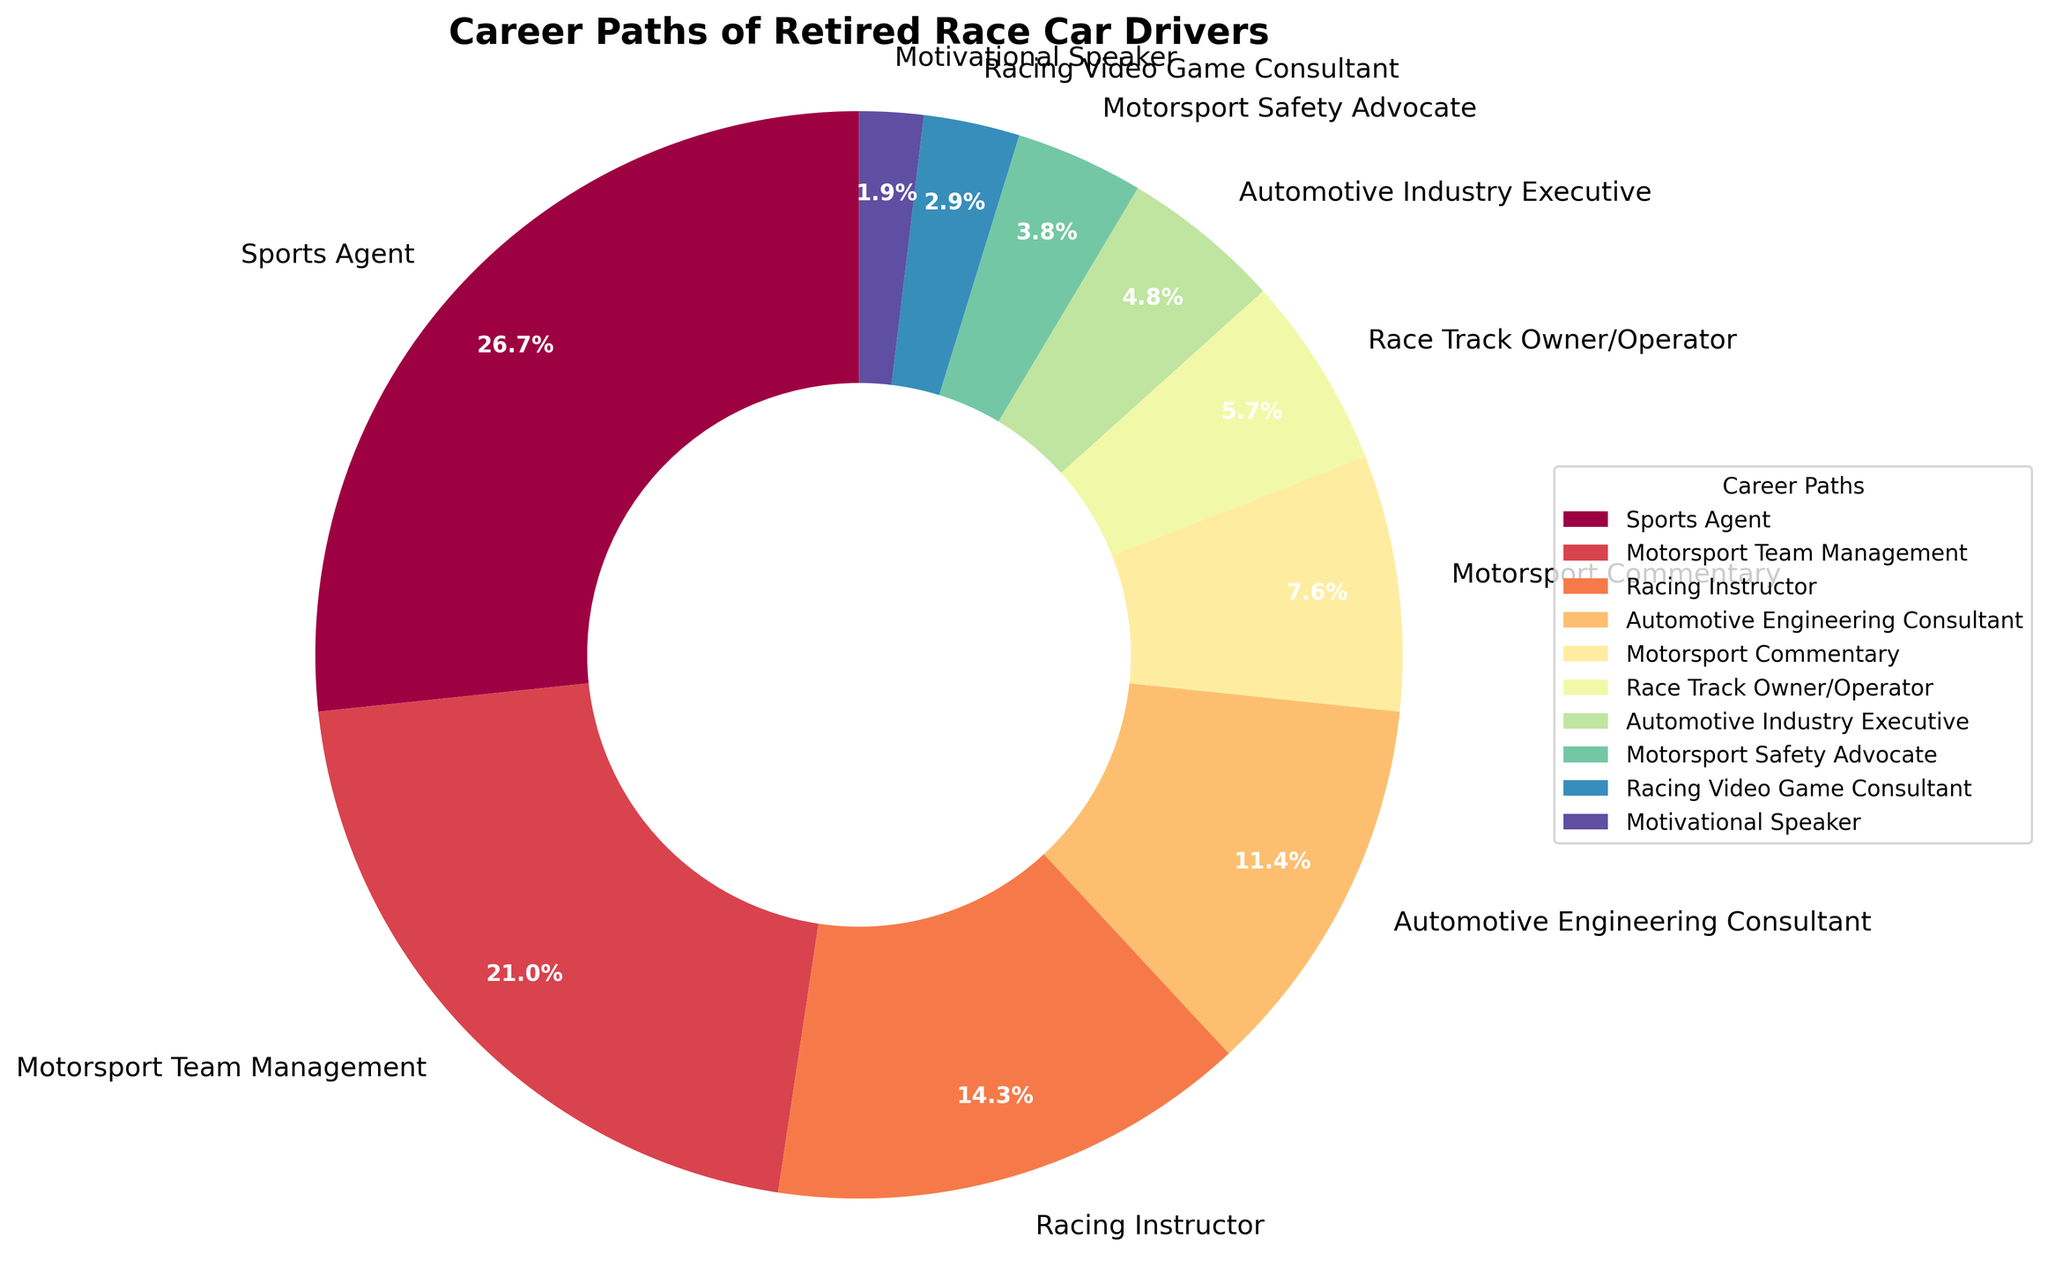What is the second most chosen career path for retired race car drivers? The pie chart segments show that "Motorsport Team Management" is the second largest segment after "Sports Agent".
Answer: Motorsport Team Management Which career path has the smallest percentage of retired race car drivers? The smallest segment in the pie chart signifies "Motivational Speaker" which has the smallest percentage.
Answer: Motivational Speaker What is the combined percentage of retired race car drivers who became Racing Instructors and Automotive Engineering Consultants? The percentages for "Racing Instructor" and "Automotive Engineering Consultant" are 15% and 12% respectively. Adding them together results in 27%.
Answer: 27% Compare the percentages of retired race car drivers who became Motorsport Commentary and Racing Video Game Consultants. Which is higher and by how much? "Motorsport Commentary" has 8%, while "Racing Video Game Consultant" has 3%. The difference is 8% - 3% = 5%.
Answer: Motorsport Commentary by 5% What percentage of retired race car drivers chose careers unrelated to motorsports? List these career paths. Careers unrelated to motorsports are "Motivational Speaker" (2%) and "Automotive Industry Executive" (5%). Adding these percentages results in 2% + 5% = 7%.
Answer: 7% Are there more retired race car drivers who became Motorsports Safety Advocates or Racing Video Game Consultants? The pie chart segments show that "Motorsport Safety Advocate" is at 4% whereas "Racing Video Game Consultant" is at 3%. Therefore, there are more Motorsports Safety Advocates.
Answer: Motorsports Safety Advocates Which career path is represented by the largest wedge on the pie chart? The largest wedge corresponds to the "Sports Agent" segment, at 28%.
Answer: Sports Agent What is the difference in percentage between the most chosen and the least chosen career paths? The most chosen career path is "Sports Agent" at 28% and the least chosen is "Motivational Speaker" at 2%. The difference is 28% - 2% = 26%.
Answer: 26% How many career paths captured in the pie chart have a percentage of 10% or more? The career paths with 10% or more are "Sports Agent" (28%), "Motorsport Team Management" (22%), "Racing Instructor" (15%), and "Automotive Engineering Consultant" (12%). There are 4 paths that meet this criterion.
Answer: 4 What career path do 6% of retired race car drivers choose? In the pie chart, the segment representing 6% corresponds to "Race Track Owner/Operator".
Answer: Race Track Owner/Operator 